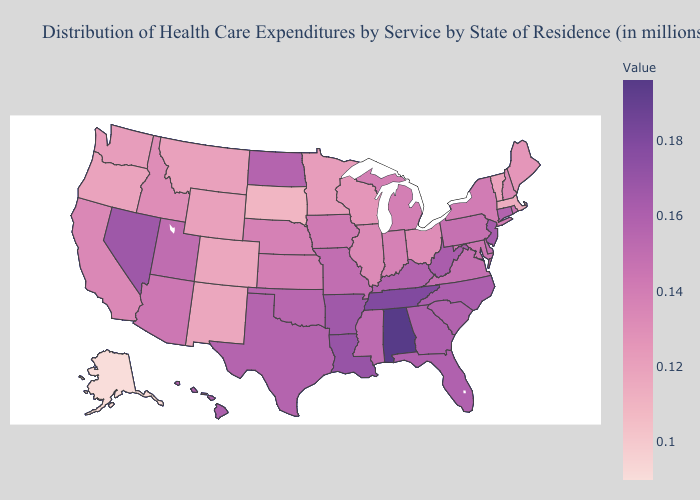Does Nevada have the lowest value in the USA?
Short answer required. No. Does Massachusetts have the lowest value in the Northeast?
Keep it brief. Yes. Among the states that border Tennessee , which have the highest value?
Write a very short answer. Alabama. Among the states that border West Virginia , which have the lowest value?
Concise answer only. Ohio. Does the map have missing data?
Short answer required. No. 